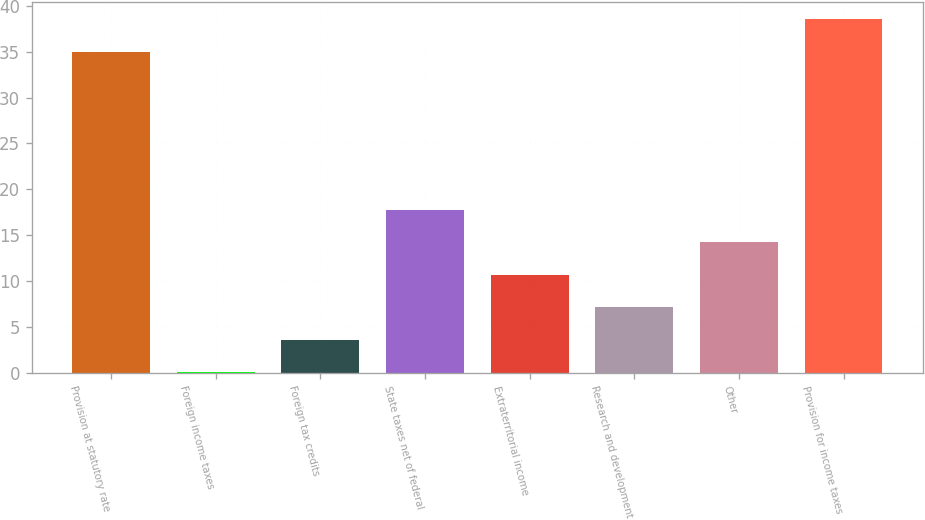<chart> <loc_0><loc_0><loc_500><loc_500><bar_chart><fcel>Provision at statutory rate<fcel>Foreign income taxes<fcel>Foreign tax credits<fcel>State taxes net of federal<fcel>Extraterritorial income<fcel>Research and development<fcel>Other<fcel>Provision for income taxes<nl><fcel>35<fcel>0.1<fcel>3.64<fcel>17.8<fcel>10.72<fcel>7.18<fcel>14.26<fcel>38.54<nl></chart> 